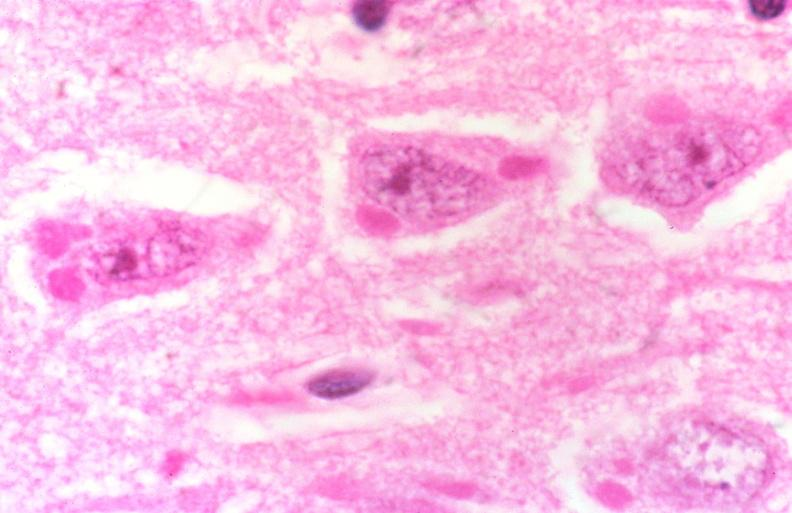s newborn cord around neck present?
Answer the question using a single word or phrase. No 